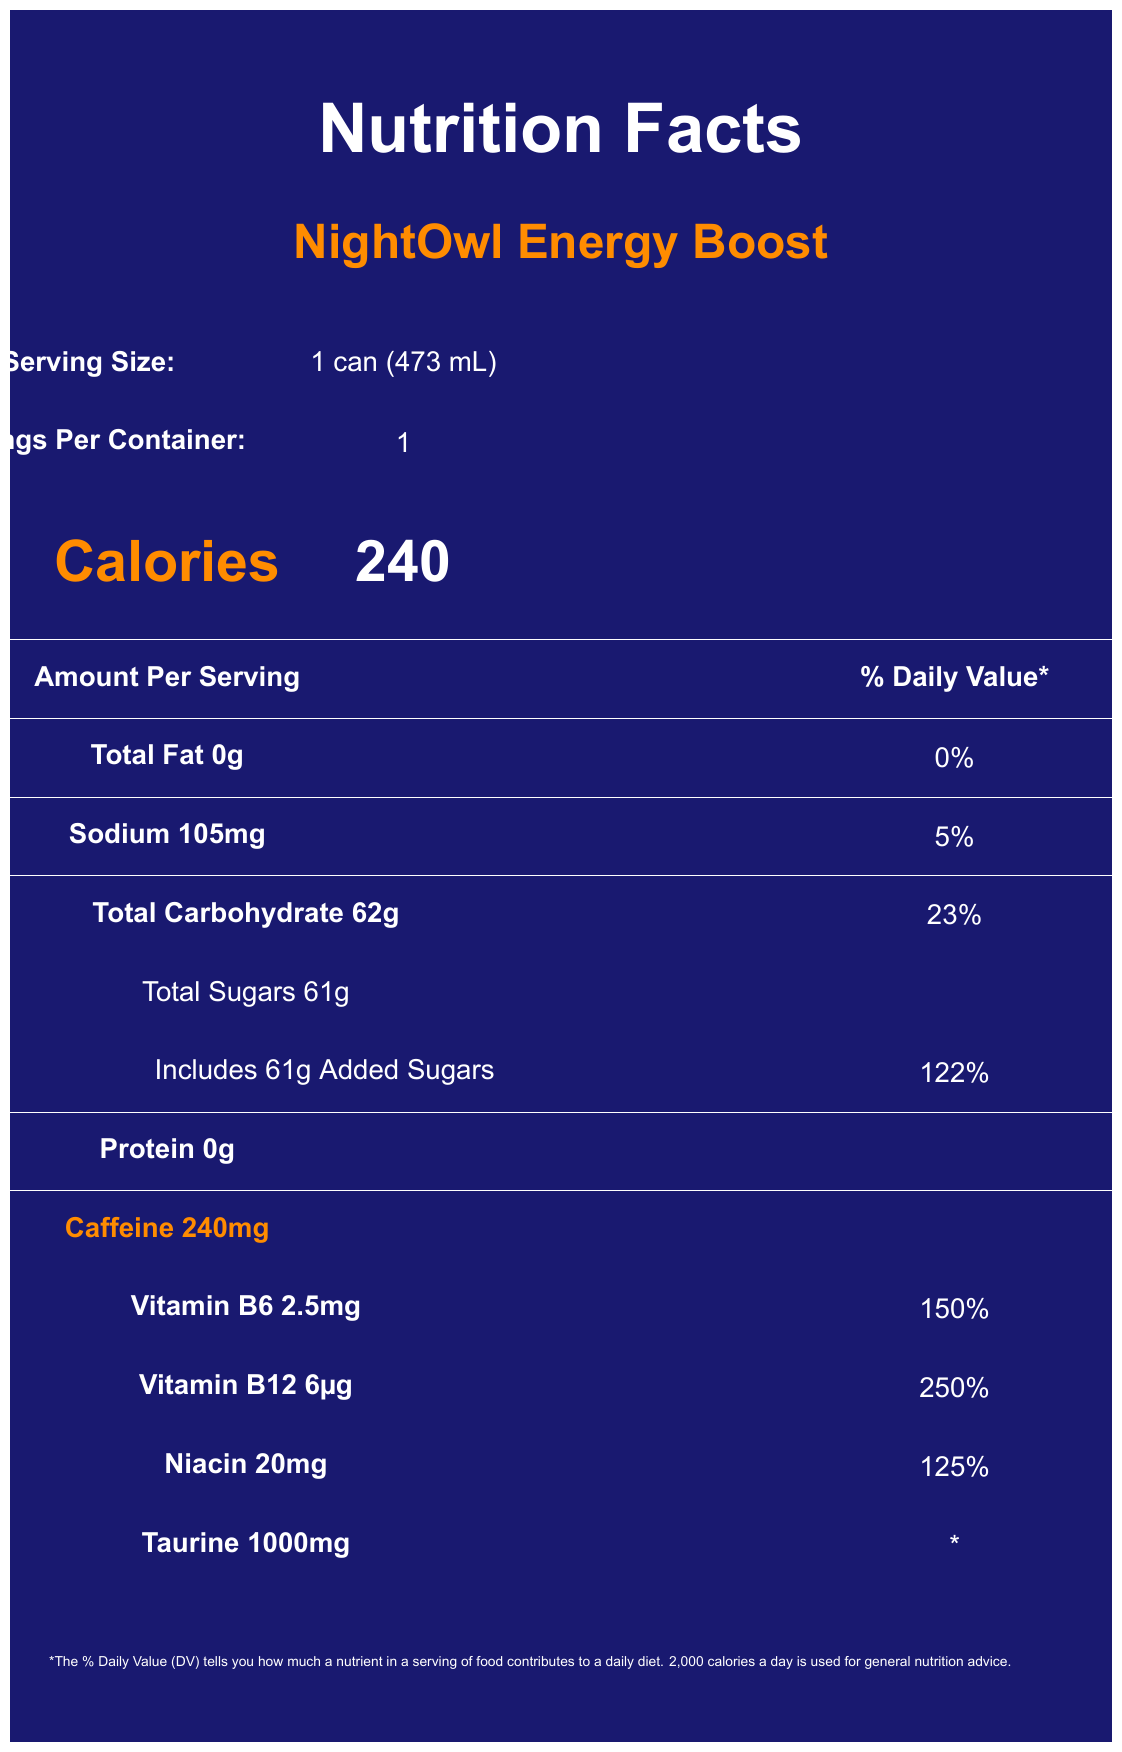what is the serving size? The document shows "Serving Size: 1 can (473 mL)" under the Serving information section.
Answer: 1 can (473 mL) how many calories are in one serving of NightOwl Energy Boost? The document lists "Calories 240" in large, orange font.
Answer: 240 what percentage of the daily value for sodium does one serving contain? The document indicates "Sodium 105mg" with a daily value of "5%" in the nutrient table.
Answer: 5% how much total carbohydrate is in one serving? The nutrient table shows "Total Carbohydrate 62g" with a daily value of "23%".
Answer: 62g how much added sugar is in NightOwl Energy Boost? The document specifies "Includes 61g Added Sugars" with a daily value of "122%" under the Total Carbohydrate section.
Answer: 61g what is the amount of protein in NightOwl Energy Boost? The document lists "Protein 0g" in the nutrient table.
Answer: 0g what is the caffeine content of this energy drink? The document mentions "Caffeine 240mg" prominently in the nutrient table.
Answer: 240mg how much Vitamin B12 does this energy drink contain? The document states "Vitamin B12 6µg" with a daily value of "250%" in the vitamins and minerals section.
Answer: 6µg what are some of the ingredients in NightOwl Energy Boost? The document lists several ingredients including "Carbonated Water, Sucrose, Glucose, Citric Acid".
Answer: Carbonated Water, Sucrose, Glucose, Citric Acid which of the following vitamins or minerals is present in the highest percentage of daily value? A. Vitamin B6 B. Vitamin B12 C. Niacin D. Taurine The vitamins and minerals section shows "Vitamin B12 250%", which is the highest percentage among the listed nutrients.
Answer: B. Vitamin B12 what is the major warning associated with this energy drink? A. Contains high sugar B. Not recommended for children or pregnant women C. May cause allergic reactions D. Do not consume more than once a day The document states "Not recommended for children, pregnant or nursing women, or individuals sensitive to caffeine. Consume responsibly. Do not mix with alcohol." in the warning section.
Answer: B. Not recommended for children or pregnant women does this energy drink have any protein? (Yes/No) The document lists "Protein 0g" which indicates there is no protein.
Answer: No summarize the key nutritional information for NightOwl Energy Boost. The document provides detailed nutritional information about NightOwl Energy Boost including its high caffeine and sugar content, and significant amounts of vitamins.
Answer: NightOwl Energy Boost contains 240 calories per can, with 0g total fat, 105mg sodium (5% DV), 62g total carbohydrates (23% DV) including 61g added sugars (122% DV), 0g protein, and 240mg caffeine. The energy drink also includes high percentages of Vitamin B6 (150%), Vitamin B12 (250%), and Niacin (125%). It is marketed for its high caffeine content and added vitamins, though it contains significant added sugars. what is the manufacturing address of NightOwl Energy Boost? The document specifies the manufacturer address as "123 Research Way, Collegetown, ST 12345" under the manufacturer section.
Answer: 123 Research Way, Collegetown, ST 12345 what is the taurine content in NightOwl Energy Boost? The document lists "Taurine 1000mg" under the vitamins and minerals section.
Answer: 1000mg how is NightOwl Energy Boost intended to be consumed according to the document? The document provides a warning section that outlines consumption guidelines.
Answer: Not recommended for children, pregnant or nursing women, or individuals sensitive to caffeine. Consume responsibly. Do not mix with alcohol. is the taurine's daily value established? The document specifically states with an asterisk that "* Daily Value not established" for Taurine.
Answer: No what is the product tagline for NightOwl Energy Boost? The document includes "Fuel your late-night research sessions!" as the product tagline.
Answer: Fuel your late-night research sessions! how many servings are there per container? The document lists "Servings Per Container: 1" in the serving information section.
Answer: 1 